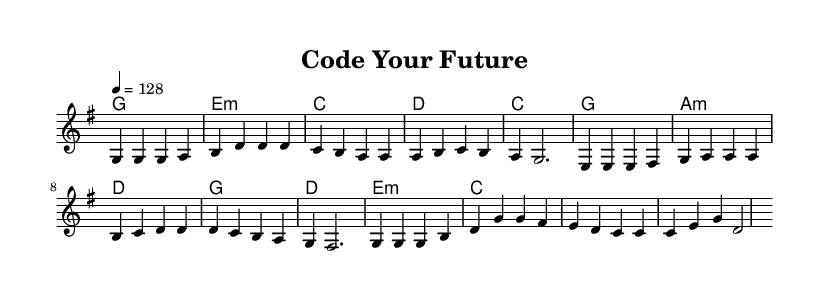What is the key signature of this music? The key signature is G major, which has one sharp (F#). This can be identified at the beginning of the staff, where the clef is indicated along with the key signature symbol.
Answer: G major What is the time signature of this music? The time signature is 4/4, shown at the beginning of the music. It indicates that there are four beats in each measure and a quarter note receives one beat.
Answer: 4/4 What is the tempo marking for this piece? The tempo marking is indicated as "4 = 128," which tells us that there should be 128 beats per minute, setting a moderate to fast pace for the performance.
Answer: 128 How many measures are in the chorus section? The chorus consists of four measures, which can be identified by counting the bar lines in the section labeled as "Chorus." Each set of notes between two bar lines constitutes one measure.
Answer: Four What is the last chord in the harmony section? The last chord in the harmony section is C major, which can be seen at the end of the chord progression, confirming that it matches the notes being played in the melody during that measure.
Answer: C What lyrical theme is prevalent in the verse of this piece? The lyrics in the verse focus on themes of coding and writing one's story, indicated by phrases such as "Lines of code" and "debugging dreams." This reflects the overall motivational message connecting technology to personal growth.
Answer: Coding and dreams What instrument is primarily used to perform the melody? The melody is typically performed on a treble instrument, often a piano or synthesizer in K-Pop, based on the notation indicated in the staff within the score.
Answer: Treble instrument 